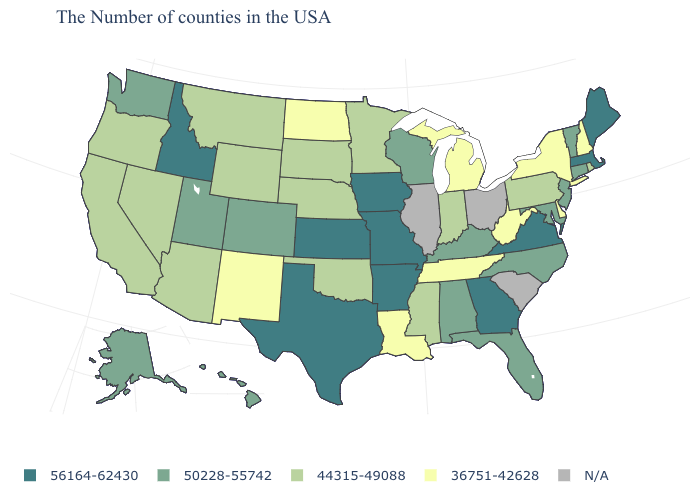What is the value of Alaska?
Short answer required. 50228-55742. What is the value of Oregon?
Write a very short answer. 44315-49088. Name the states that have a value in the range 56164-62430?
Be succinct. Maine, Massachusetts, Virginia, Georgia, Missouri, Arkansas, Iowa, Kansas, Texas, Idaho. What is the value of New Mexico?
Keep it brief. 36751-42628. Name the states that have a value in the range 44315-49088?
Give a very brief answer. Rhode Island, Pennsylvania, Indiana, Mississippi, Minnesota, Nebraska, Oklahoma, South Dakota, Wyoming, Montana, Arizona, Nevada, California, Oregon. Name the states that have a value in the range 56164-62430?
Quick response, please. Maine, Massachusetts, Virginia, Georgia, Missouri, Arkansas, Iowa, Kansas, Texas, Idaho. Does New Hampshire have the lowest value in the Northeast?
Short answer required. Yes. What is the value of Wyoming?
Short answer required. 44315-49088. What is the value of New Hampshire?
Short answer required. 36751-42628. Name the states that have a value in the range 50228-55742?
Answer briefly. Vermont, Connecticut, New Jersey, Maryland, North Carolina, Florida, Kentucky, Alabama, Wisconsin, Colorado, Utah, Washington, Alaska, Hawaii. How many symbols are there in the legend?
Keep it brief. 5. What is the lowest value in the USA?
Be succinct. 36751-42628. What is the value of South Dakota?
Answer briefly. 44315-49088. Name the states that have a value in the range 36751-42628?
Answer briefly. New Hampshire, New York, Delaware, West Virginia, Michigan, Tennessee, Louisiana, North Dakota, New Mexico. What is the value of West Virginia?
Give a very brief answer. 36751-42628. 